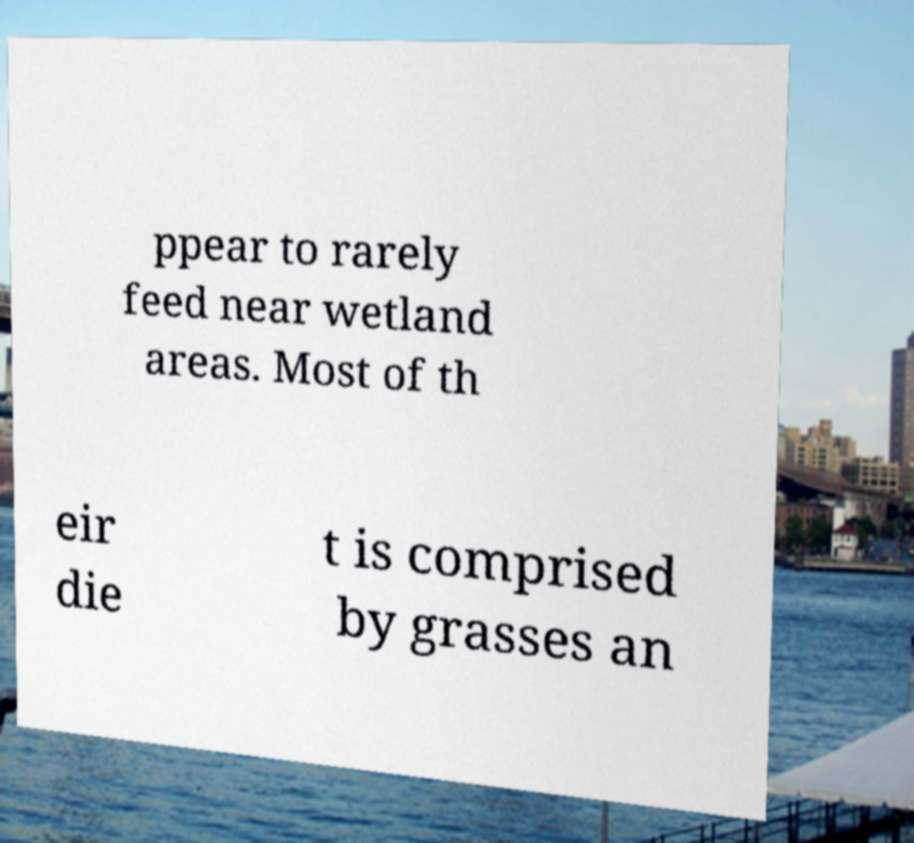For documentation purposes, I need the text within this image transcribed. Could you provide that? ppear to rarely feed near wetland areas. Most of th eir die t is comprised by grasses an 